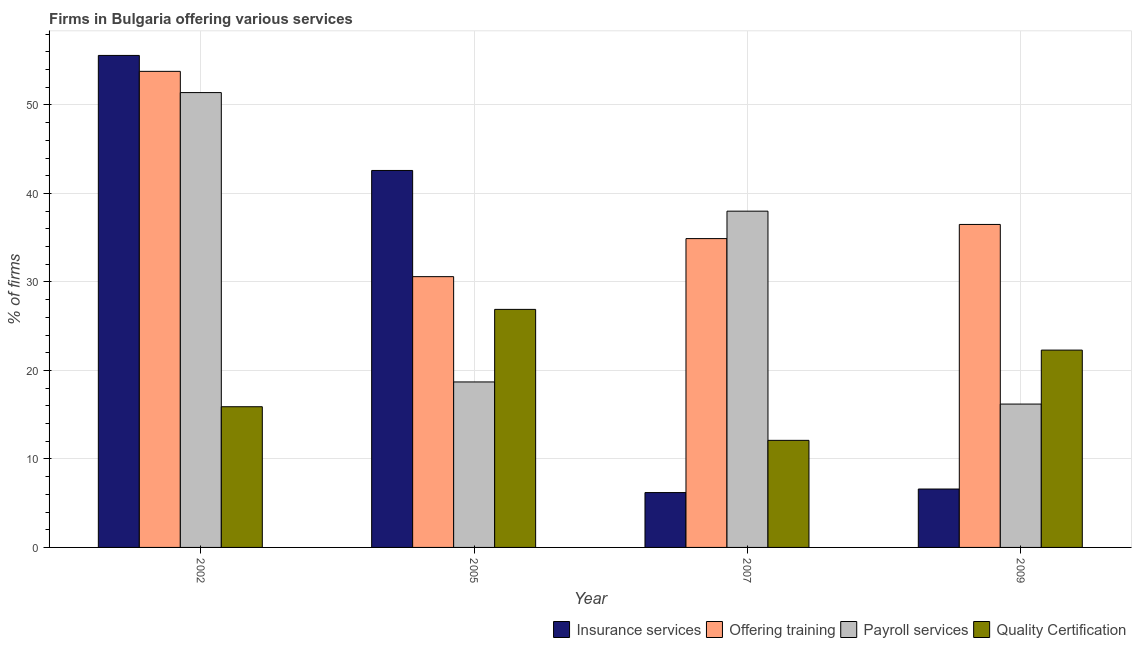How many different coloured bars are there?
Give a very brief answer. 4. How many groups of bars are there?
Your answer should be compact. 4. What is the label of the 2nd group of bars from the left?
Your answer should be compact. 2005. In how many cases, is the number of bars for a given year not equal to the number of legend labels?
Provide a short and direct response. 0. Across all years, what is the maximum percentage of firms offering insurance services?
Keep it short and to the point. 55.6. Across all years, what is the minimum percentage of firms offering quality certification?
Your answer should be compact. 12.1. In which year was the percentage of firms offering quality certification minimum?
Offer a very short reply. 2007. What is the total percentage of firms offering quality certification in the graph?
Offer a very short reply. 77.2. What is the difference between the percentage of firms offering payroll services in 2005 and that in 2007?
Offer a very short reply. -19.3. What is the difference between the percentage of firms offering insurance services in 2005 and the percentage of firms offering payroll services in 2002?
Your answer should be compact. -13. What is the average percentage of firms offering insurance services per year?
Your response must be concise. 27.75. In the year 2009, what is the difference between the percentage of firms offering quality certification and percentage of firms offering training?
Make the answer very short. 0. In how many years, is the percentage of firms offering training greater than 24 %?
Your answer should be compact. 4. What is the ratio of the percentage of firms offering payroll services in 2005 to that in 2007?
Offer a terse response. 0.49. What is the difference between the highest and the second highest percentage of firms offering training?
Your answer should be very brief. 17.3. What is the difference between the highest and the lowest percentage of firms offering payroll services?
Give a very brief answer. 35.2. What does the 4th bar from the left in 2009 represents?
Offer a very short reply. Quality Certification. What does the 3rd bar from the right in 2002 represents?
Your answer should be compact. Offering training. Is it the case that in every year, the sum of the percentage of firms offering insurance services and percentage of firms offering training is greater than the percentage of firms offering payroll services?
Keep it short and to the point. Yes. How many bars are there?
Give a very brief answer. 16. What is the difference between two consecutive major ticks on the Y-axis?
Make the answer very short. 10. Are the values on the major ticks of Y-axis written in scientific E-notation?
Offer a terse response. No. Does the graph contain any zero values?
Your answer should be compact. No. Where does the legend appear in the graph?
Provide a short and direct response. Bottom right. How are the legend labels stacked?
Your answer should be compact. Horizontal. What is the title of the graph?
Your answer should be compact. Firms in Bulgaria offering various services . What is the label or title of the Y-axis?
Keep it short and to the point. % of firms. What is the % of firms in Insurance services in 2002?
Keep it short and to the point. 55.6. What is the % of firms of Offering training in 2002?
Your response must be concise. 53.8. What is the % of firms in Payroll services in 2002?
Your answer should be very brief. 51.4. What is the % of firms in Insurance services in 2005?
Provide a succinct answer. 42.6. What is the % of firms in Offering training in 2005?
Your answer should be very brief. 30.6. What is the % of firms of Quality Certification in 2005?
Your answer should be very brief. 26.9. What is the % of firms in Insurance services in 2007?
Provide a short and direct response. 6.2. What is the % of firms in Offering training in 2007?
Offer a terse response. 34.9. What is the % of firms in Payroll services in 2007?
Provide a succinct answer. 38. What is the % of firms of Quality Certification in 2007?
Keep it short and to the point. 12.1. What is the % of firms of Insurance services in 2009?
Offer a terse response. 6.6. What is the % of firms in Offering training in 2009?
Your response must be concise. 36.5. What is the % of firms of Quality Certification in 2009?
Keep it short and to the point. 22.3. Across all years, what is the maximum % of firms in Insurance services?
Provide a succinct answer. 55.6. Across all years, what is the maximum % of firms in Offering training?
Give a very brief answer. 53.8. Across all years, what is the maximum % of firms in Payroll services?
Your answer should be very brief. 51.4. Across all years, what is the maximum % of firms of Quality Certification?
Your response must be concise. 26.9. Across all years, what is the minimum % of firms in Offering training?
Provide a succinct answer. 30.6. What is the total % of firms of Insurance services in the graph?
Keep it short and to the point. 111. What is the total % of firms of Offering training in the graph?
Ensure brevity in your answer.  155.8. What is the total % of firms in Payroll services in the graph?
Keep it short and to the point. 124.3. What is the total % of firms of Quality Certification in the graph?
Your answer should be very brief. 77.2. What is the difference between the % of firms in Offering training in 2002 and that in 2005?
Ensure brevity in your answer.  23.2. What is the difference between the % of firms in Payroll services in 2002 and that in 2005?
Give a very brief answer. 32.7. What is the difference between the % of firms of Insurance services in 2002 and that in 2007?
Make the answer very short. 49.4. What is the difference between the % of firms in Offering training in 2002 and that in 2007?
Your response must be concise. 18.9. What is the difference between the % of firms in Payroll services in 2002 and that in 2007?
Offer a very short reply. 13.4. What is the difference between the % of firms in Offering training in 2002 and that in 2009?
Provide a short and direct response. 17.3. What is the difference between the % of firms of Payroll services in 2002 and that in 2009?
Your answer should be very brief. 35.2. What is the difference between the % of firms of Insurance services in 2005 and that in 2007?
Offer a terse response. 36.4. What is the difference between the % of firms in Offering training in 2005 and that in 2007?
Provide a succinct answer. -4.3. What is the difference between the % of firms in Payroll services in 2005 and that in 2007?
Your response must be concise. -19.3. What is the difference between the % of firms in Quality Certification in 2005 and that in 2007?
Keep it short and to the point. 14.8. What is the difference between the % of firms of Quality Certification in 2005 and that in 2009?
Your answer should be compact. 4.6. What is the difference between the % of firms in Insurance services in 2007 and that in 2009?
Offer a terse response. -0.4. What is the difference between the % of firms in Payroll services in 2007 and that in 2009?
Keep it short and to the point. 21.8. What is the difference between the % of firms of Insurance services in 2002 and the % of firms of Payroll services in 2005?
Ensure brevity in your answer.  36.9. What is the difference between the % of firms of Insurance services in 2002 and the % of firms of Quality Certification in 2005?
Offer a terse response. 28.7. What is the difference between the % of firms of Offering training in 2002 and the % of firms of Payroll services in 2005?
Your answer should be very brief. 35.1. What is the difference between the % of firms of Offering training in 2002 and the % of firms of Quality Certification in 2005?
Ensure brevity in your answer.  26.9. What is the difference between the % of firms in Payroll services in 2002 and the % of firms in Quality Certification in 2005?
Offer a very short reply. 24.5. What is the difference between the % of firms in Insurance services in 2002 and the % of firms in Offering training in 2007?
Offer a terse response. 20.7. What is the difference between the % of firms in Insurance services in 2002 and the % of firms in Payroll services in 2007?
Provide a short and direct response. 17.6. What is the difference between the % of firms of Insurance services in 2002 and the % of firms of Quality Certification in 2007?
Offer a very short reply. 43.5. What is the difference between the % of firms of Offering training in 2002 and the % of firms of Quality Certification in 2007?
Make the answer very short. 41.7. What is the difference between the % of firms in Payroll services in 2002 and the % of firms in Quality Certification in 2007?
Offer a very short reply. 39.3. What is the difference between the % of firms in Insurance services in 2002 and the % of firms in Offering training in 2009?
Your response must be concise. 19.1. What is the difference between the % of firms in Insurance services in 2002 and the % of firms in Payroll services in 2009?
Give a very brief answer. 39.4. What is the difference between the % of firms of Insurance services in 2002 and the % of firms of Quality Certification in 2009?
Your answer should be very brief. 33.3. What is the difference between the % of firms in Offering training in 2002 and the % of firms in Payroll services in 2009?
Offer a very short reply. 37.6. What is the difference between the % of firms of Offering training in 2002 and the % of firms of Quality Certification in 2009?
Your answer should be very brief. 31.5. What is the difference between the % of firms in Payroll services in 2002 and the % of firms in Quality Certification in 2009?
Your response must be concise. 29.1. What is the difference between the % of firms of Insurance services in 2005 and the % of firms of Payroll services in 2007?
Make the answer very short. 4.6. What is the difference between the % of firms in Insurance services in 2005 and the % of firms in Quality Certification in 2007?
Ensure brevity in your answer.  30.5. What is the difference between the % of firms in Offering training in 2005 and the % of firms in Payroll services in 2007?
Your answer should be very brief. -7.4. What is the difference between the % of firms in Offering training in 2005 and the % of firms in Quality Certification in 2007?
Ensure brevity in your answer.  18.5. What is the difference between the % of firms in Payroll services in 2005 and the % of firms in Quality Certification in 2007?
Provide a succinct answer. 6.6. What is the difference between the % of firms of Insurance services in 2005 and the % of firms of Payroll services in 2009?
Offer a terse response. 26.4. What is the difference between the % of firms of Insurance services in 2005 and the % of firms of Quality Certification in 2009?
Your response must be concise. 20.3. What is the difference between the % of firms of Payroll services in 2005 and the % of firms of Quality Certification in 2009?
Your answer should be very brief. -3.6. What is the difference between the % of firms of Insurance services in 2007 and the % of firms of Offering training in 2009?
Offer a very short reply. -30.3. What is the difference between the % of firms of Insurance services in 2007 and the % of firms of Payroll services in 2009?
Ensure brevity in your answer.  -10. What is the difference between the % of firms of Insurance services in 2007 and the % of firms of Quality Certification in 2009?
Keep it short and to the point. -16.1. What is the difference between the % of firms in Offering training in 2007 and the % of firms in Payroll services in 2009?
Your response must be concise. 18.7. What is the difference between the % of firms in Offering training in 2007 and the % of firms in Quality Certification in 2009?
Your answer should be compact. 12.6. What is the difference between the % of firms of Payroll services in 2007 and the % of firms of Quality Certification in 2009?
Give a very brief answer. 15.7. What is the average % of firms in Insurance services per year?
Your answer should be very brief. 27.75. What is the average % of firms in Offering training per year?
Make the answer very short. 38.95. What is the average % of firms in Payroll services per year?
Provide a succinct answer. 31.07. What is the average % of firms in Quality Certification per year?
Provide a succinct answer. 19.3. In the year 2002, what is the difference between the % of firms of Insurance services and % of firms of Offering training?
Provide a succinct answer. 1.8. In the year 2002, what is the difference between the % of firms in Insurance services and % of firms in Quality Certification?
Ensure brevity in your answer.  39.7. In the year 2002, what is the difference between the % of firms of Offering training and % of firms of Quality Certification?
Your answer should be very brief. 37.9. In the year 2002, what is the difference between the % of firms of Payroll services and % of firms of Quality Certification?
Provide a succinct answer. 35.5. In the year 2005, what is the difference between the % of firms of Insurance services and % of firms of Payroll services?
Your answer should be very brief. 23.9. In the year 2005, what is the difference between the % of firms of Insurance services and % of firms of Quality Certification?
Your answer should be compact. 15.7. In the year 2005, what is the difference between the % of firms of Payroll services and % of firms of Quality Certification?
Offer a terse response. -8.2. In the year 2007, what is the difference between the % of firms in Insurance services and % of firms in Offering training?
Offer a very short reply. -28.7. In the year 2007, what is the difference between the % of firms in Insurance services and % of firms in Payroll services?
Ensure brevity in your answer.  -31.8. In the year 2007, what is the difference between the % of firms of Insurance services and % of firms of Quality Certification?
Your response must be concise. -5.9. In the year 2007, what is the difference between the % of firms of Offering training and % of firms of Payroll services?
Give a very brief answer. -3.1. In the year 2007, what is the difference between the % of firms of Offering training and % of firms of Quality Certification?
Your answer should be compact. 22.8. In the year 2007, what is the difference between the % of firms in Payroll services and % of firms in Quality Certification?
Your response must be concise. 25.9. In the year 2009, what is the difference between the % of firms of Insurance services and % of firms of Offering training?
Your answer should be compact. -29.9. In the year 2009, what is the difference between the % of firms in Insurance services and % of firms in Payroll services?
Offer a very short reply. -9.6. In the year 2009, what is the difference between the % of firms of Insurance services and % of firms of Quality Certification?
Your response must be concise. -15.7. In the year 2009, what is the difference between the % of firms of Offering training and % of firms of Payroll services?
Your answer should be compact. 20.3. In the year 2009, what is the difference between the % of firms of Payroll services and % of firms of Quality Certification?
Make the answer very short. -6.1. What is the ratio of the % of firms in Insurance services in 2002 to that in 2005?
Provide a succinct answer. 1.31. What is the ratio of the % of firms in Offering training in 2002 to that in 2005?
Make the answer very short. 1.76. What is the ratio of the % of firms of Payroll services in 2002 to that in 2005?
Your answer should be very brief. 2.75. What is the ratio of the % of firms of Quality Certification in 2002 to that in 2005?
Your answer should be very brief. 0.59. What is the ratio of the % of firms in Insurance services in 2002 to that in 2007?
Provide a short and direct response. 8.97. What is the ratio of the % of firms of Offering training in 2002 to that in 2007?
Offer a very short reply. 1.54. What is the ratio of the % of firms of Payroll services in 2002 to that in 2007?
Give a very brief answer. 1.35. What is the ratio of the % of firms in Quality Certification in 2002 to that in 2007?
Make the answer very short. 1.31. What is the ratio of the % of firms of Insurance services in 2002 to that in 2009?
Your answer should be very brief. 8.42. What is the ratio of the % of firms in Offering training in 2002 to that in 2009?
Offer a terse response. 1.47. What is the ratio of the % of firms in Payroll services in 2002 to that in 2009?
Your response must be concise. 3.17. What is the ratio of the % of firms of Quality Certification in 2002 to that in 2009?
Keep it short and to the point. 0.71. What is the ratio of the % of firms in Insurance services in 2005 to that in 2007?
Offer a very short reply. 6.87. What is the ratio of the % of firms in Offering training in 2005 to that in 2007?
Your answer should be very brief. 0.88. What is the ratio of the % of firms of Payroll services in 2005 to that in 2007?
Make the answer very short. 0.49. What is the ratio of the % of firms in Quality Certification in 2005 to that in 2007?
Your answer should be very brief. 2.22. What is the ratio of the % of firms in Insurance services in 2005 to that in 2009?
Your response must be concise. 6.45. What is the ratio of the % of firms in Offering training in 2005 to that in 2009?
Your answer should be compact. 0.84. What is the ratio of the % of firms in Payroll services in 2005 to that in 2009?
Your response must be concise. 1.15. What is the ratio of the % of firms of Quality Certification in 2005 to that in 2009?
Provide a short and direct response. 1.21. What is the ratio of the % of firms in Insurance services in 2007 to that in 2009?
Your answer should be compact. 0.94. What is the ratio of the % of firms in Offering training in 2007 to that in 2009?
Provide a short and direct response. 0.96. What is the ratio of the % of firms of Payroll services in 2007 to that in 2009?
Your answer should be compact. 2.35. What is the ratio of the % of firms of Quality Certification in 2007 to that in 2009?
Provide a short and direct response. 0.54. What is the difference between the highest and the second highest % of firms of Insurance services?
Provide a succinct answer. 13. What is the difference between the highest and the second highest % of firms in Payroll services?
Offer a terse response. 13.4. What is the difference between the highest and the lowest % of firms of Insurance services?
Provide a succinct answer. 49.4. What is the difference between the highest and the lowest % of firms of Offering training?
Make the answer very short. 23.2. What is the difference between the highest and the lowest % of firms of Payroll services?
Provide a succinct answer. 35.2. What is the difference between the highest and the lowest % of firms in Quality Certification?
Provide a succinct answer. 14.8. 